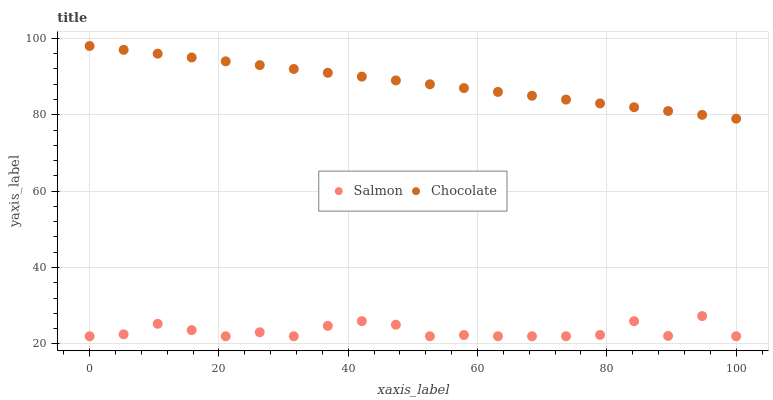Does Salmon have the minimum area under the curve?
Answer yes or no. Yes. Does Chocolate have the maximum area under the curve?
Answer yes or no. Yes. Does Chocolate have the minimum area under the curve?
Answer yes or no. No. Is Chocolate the smoothest?
Answer yes or no. Yes. Is Salmon the roughest?
Answer yes or no. Yes. Is Chocolate the roughest?
Answer yes or no. No. Does Salmon have the lowest value?
Answer yes or no. Yes. Does Chocolate have the lowest value?
Answer yes or no. No. Does Chocolate have the highest value?
Answer yes or no. Yes. Is Salmon less than Chocolate?
Answer yes or no. Yes. Is Chocolate greater than Salmon?
Answer yes or no. Yes. Does Salmon intersect Chocolate?
Answer yes or no. No. 